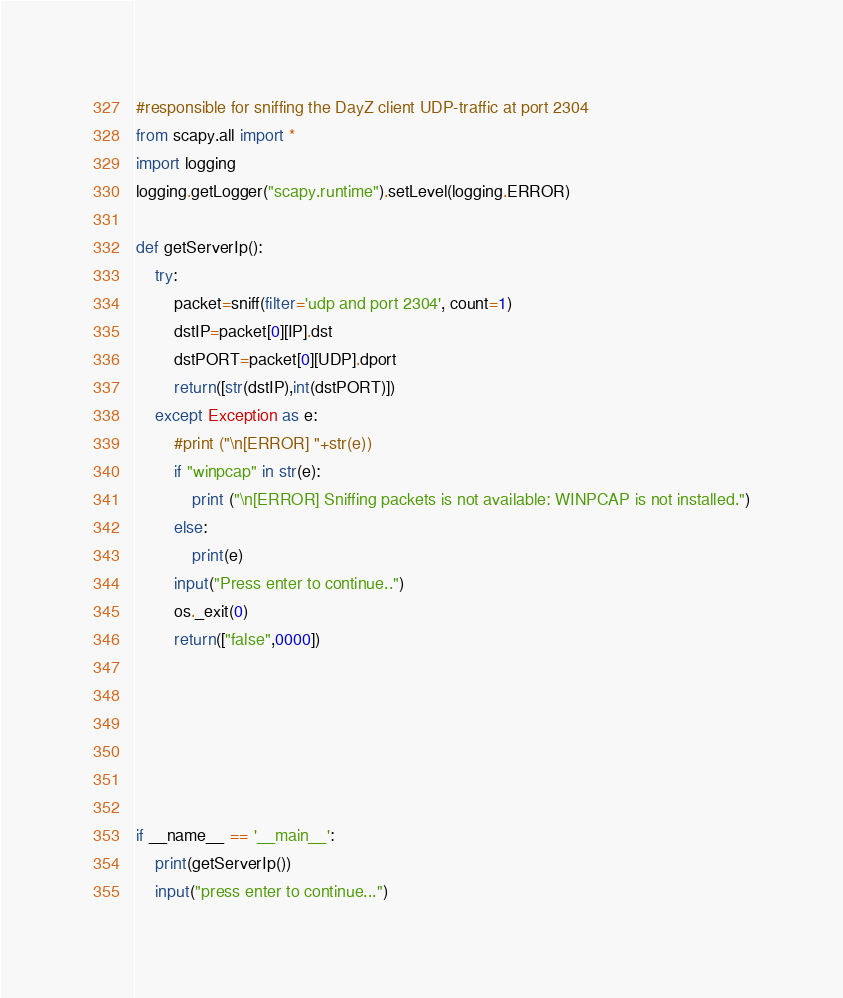<code> <loc_0><loc_0><loc_500><loc_500><_Python_>#responsible for sniffing the DayZ client UDP-traffic at port 2304
from scapy.all import *
import logging
logging.getLogger("scapy.runtime").setLevel(logging.ERROR)

def getServerIp():
	try:
		packet=sniff(filter='udp and port 2304', count=1)
		dstIP=packet[0][IP].dst
		dstPORT=packet[0][UDP].dport
		return([str(dstIP),int(dstPORT)])
	except Exception as e:
		#print ("\n[ERROR] "+str(e))
		if "winpcap" in str(e):
			print ("\n[ERROR] Sniffing packets is not available: WINPCAP is not installed.")
		else:
			print(e)
		input("Press enter to continue..")
		os._exit(0)
		return(["false",0000])
		
		
		
	

	
if __name__ == '__main__':
	print(getServerIp())
	input("press enter to continue...")
</code> 